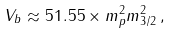<formula> <loc_0><loc_0><loc_500><loc_500>V _ { b } \approx 5 1 . 5 5 \times m _ { p } ^ { 2 } m _ { 3 / 2 } ^ { 2 } \, ,</formula> 